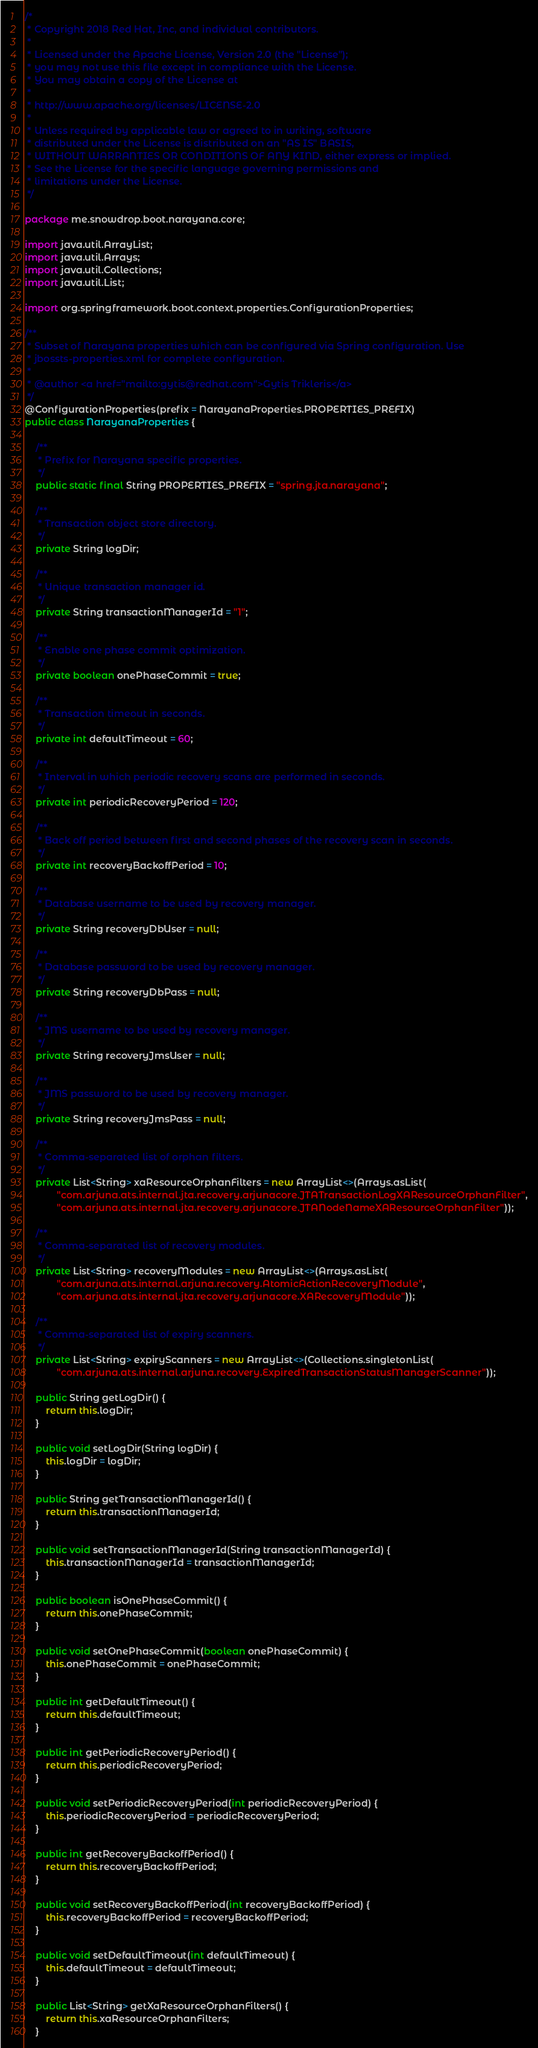<code> <loc_0><loc_0><loc_500><loc_500><_Java_>/*
 * Copyright 2018 Red Hat, Inc, and individual contributors.
 *
 * Licensed under the Apache License, Version 2.0 (the "License");
 * you may not use this file except in compliance with the License.
 * You may obtain a copy of the License at
 *
 * http://www.apache.org/licenses/LICENSE-2.0
 *
 * Unless required by applicable law or agreed to in writing, software
 * distributed under the License is distributed on an "AS IS" BASIS,
 * WITHOUT WARRANTIES OR CONDITIONS OF ANY KIND, either express or implied.
 * See the License for the specific language governing permissions and
 * limitations under the License.
 */

package me.snowdrop.boot.narayana.core;

import java.util.ArrayList;
import java.util.Arrays;
import java.util.Collections;
import java.util.List;

import org.springframework.boot.context.properties.ConfigurationProperties;

/**
 * Subset of Narayana properties which can be configured via Spring configuration. Use
 * jbossts-properties.xml for complete configuration.
 *
 * @author <a href="mailto:gytis@redhat.com">Gytis Trikleris</a>
 */
@ConfigurationProperties(prefix = NarayanaProperties.PROPERTIES_PREFIX)
public class NarayanaProperties {

    /**
     * Prefix for Narayana specific properties.
     */
    public static final String PROPERTIES_PREFIX = "spring.jta.narayana";

    /**
     * Transaction object store directory.
     */
    private String logDir;

    /**
     * Unique transaction manager id.
     */
    private String transactionManagerId = "1";

    /**
     * Enable one phase commit optimization.
     */
    private boolean onePhaseCommit = true;

    /**
     * Transaction timeout in seconds.
     */
    private int defaultTimeout = 60;

    /**
     * Interval in which periodic recovery scans are performed in seconds.
     */
    private int periodicRecoveryPeriod = 120;

    /**
     * Back off period between first and second phases of the recovery scan in seconds.
     */
    private int recoveryBackoffPeriod = 10;

    /**
     * Database username to be used by recovery manager.
     */
    private String recoveryDbUser = null;

    /**
     * Database password to be used by recovery manager.
     */
    private String recoveryDbPass = null;

    /**
     * JMS username to be used by recovery manager.
     */
    private String recoveryJmsUser = null;

    /**
     * JMS password to be used by recovery manager.
     */
    private String recoveryJmsPass = null;

    /**
     * Comma-separated list of orphan filters.
     */
    private List<String> xaResourceOrphanFilters = new ArrayList<>(Arrays.asList(
            "com.arjuna.ats.internal.jta.recovery.arjunacore.JTATransactionLogXAResourceOrphanFilter",
            "com.arjuna.ats.internal.jta.recovery.arjunacore.JTANodeNameXAResourceOrphanFilter"));

    /**
     * Comma-separated list of recovery modules.
     */
    private List<String> recoveryModules = new ArrayList<>(Arrays.asList(
            "com.arjuna.ats.internal.arjuna.recovery.AtomicActionRecoveryModule",
            "com.arjuna.ats.internal.jta.recovery.arjunacore.XARecoveryModule"));

    /**
     * Comma-separated list of expiry scanners.
     */
    private List<String> expiryScanners = new ArrayList<>(Collections.singletonList(
            "com.arjuna.ats.internal.arjuna.recovery.ExpiredTransactionStatusManagerScanner"));

    public String getLogDir() {
        return this.logDir;
    }

    public void setLogDir(String logDir) {
        this.logDir = logDir;
    }

    public String getTransactionManagerId() {
        return this.transactionManagerId;
    }

    public void setTransactionManagerId(String transactionManagerId) {
        this.transactionManagerId = transactionManagerId;
    }

    public boolean isOnePhaseCommit() {
        return this.onePhaseCommit;
    }

    public void setOnePhaseCommit(boolean onePhaseCommit) {
        this.onePhaseCommit = onePhaseCommit;
    }

    public int getDefaultTimeout() {
        return this.defaultTimeout;
    }

    public int getPeriodicRecoveryPeriod() {
        return this.periodicRecoveryPeriod;
    }

    public void setPeriodicRecoveryPeriod(int periodicRecoveryPeriod) {
        this.periodicRecoveryPeriod = periodicRecoveryPeriod;
    }

    public int getRecoveryBackoffPeriod() {
        return this.recoveryBackoffPeriod;
    }

    public void setRecoveryBackoffPeriod(int recoveryBackoffPeriod) {
        this.recoveryBackoffPeriod = recoveryBackoffPeriod;
    }

    public void setDefaultTimeout(int defaultTimeout) {
        this.defaultTimeout = defaultTimeout;
    }

    public List<String> getXaResourceOrphanFilters() {
        return this.xaResourceOrphanFilters;
    }
</code> 